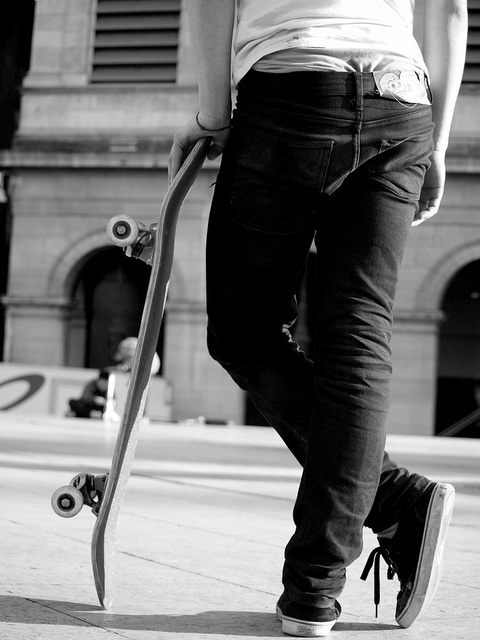Describe the objects in this image and their specific colors. I can see people in black, gray, darkgray, and white tones, skateboard in black, gray, darkgray, and lightgray tones, bench in black, lightgray, darkgray, and gray tones, and people in black, gray, darkgray, and white tones in this image. 